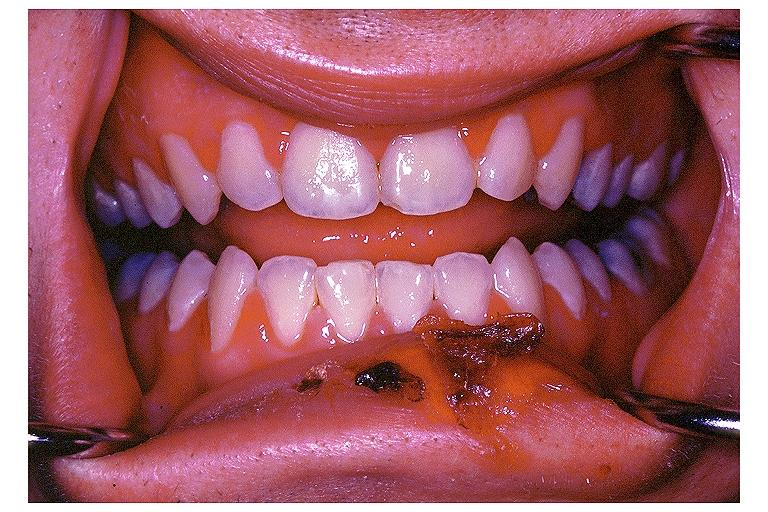what is present?
Answer the question using a single word or phrase. Oral 